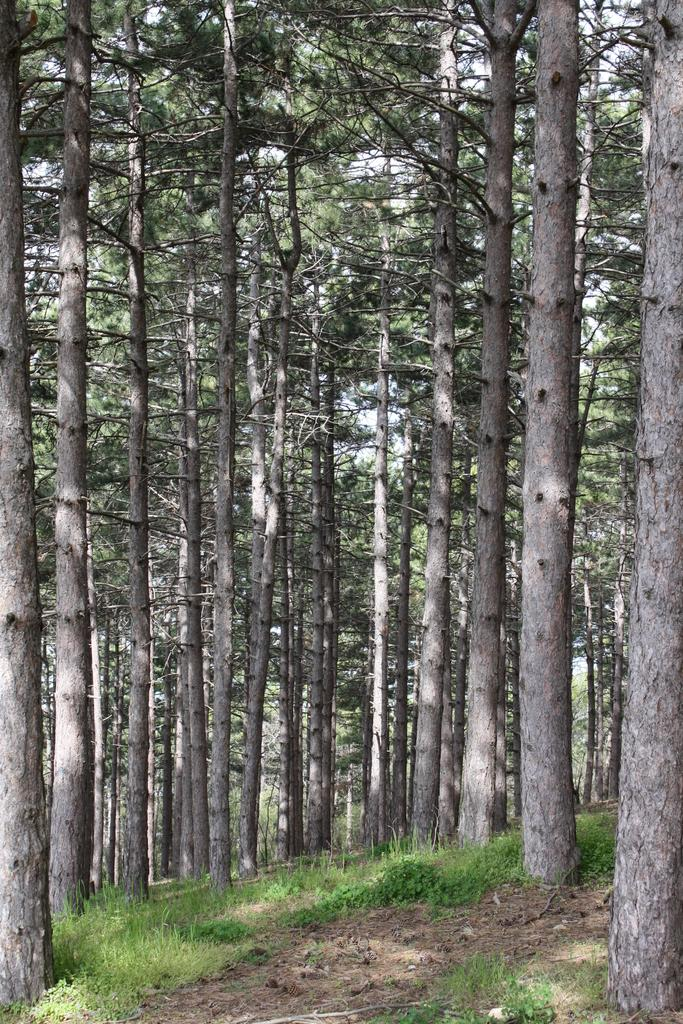What type of vegetation is present in the image? There are trees in the image. What is covering the ground in the image? There is grass on the ground in the image. What type of business is being conducted in the image? There is no indication of any business activity in the image; it features trees and grass. What type of slope can be seen in the image? There is no slope present in the image; it features trees and grass on a flat surface. 